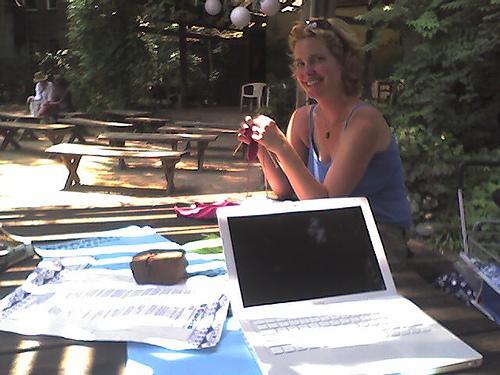How many people are in the picture?
Be succinct. 2. What kind of computer is featured in the picture?
Concise answer only. Laptop. What type of jewelry is the woman wearing?
Answer briefly. Necklace. 